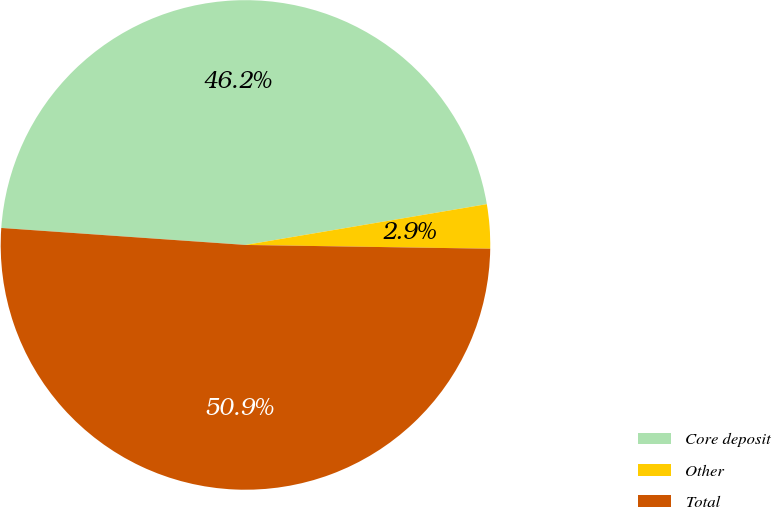Convert chart to OTSL. <chart><loc_0><loc_0><loc_500><loc_500><pie_chart><fcel>Core deposit<fcel>Other<fcel>Total<nl><fcel>46.23%<fcel>2.91%<fcel>50.86%<nl></chart> 